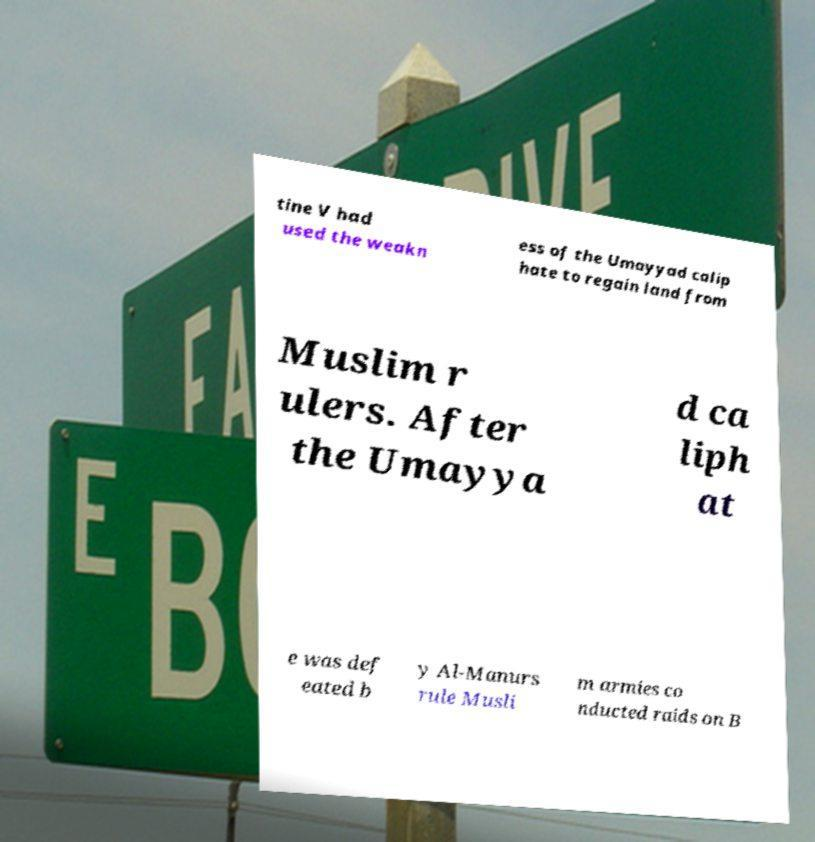Can you accurately transcribe the text from the provided image for me? tine V had used the weakn ess of the Umayyad calip hate to regain land from Muslim r ulers. After the Umayya d ca liph at e was def eated b y Al-Manurs rule Musli m armies co nducted raids on B 